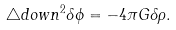<formula> <loc_0><loc_0><loc_500><loc_500>\triangle d o w n ^ { 2 } \delta \phi = - 4 \pi G \delta \rho .</formula> 